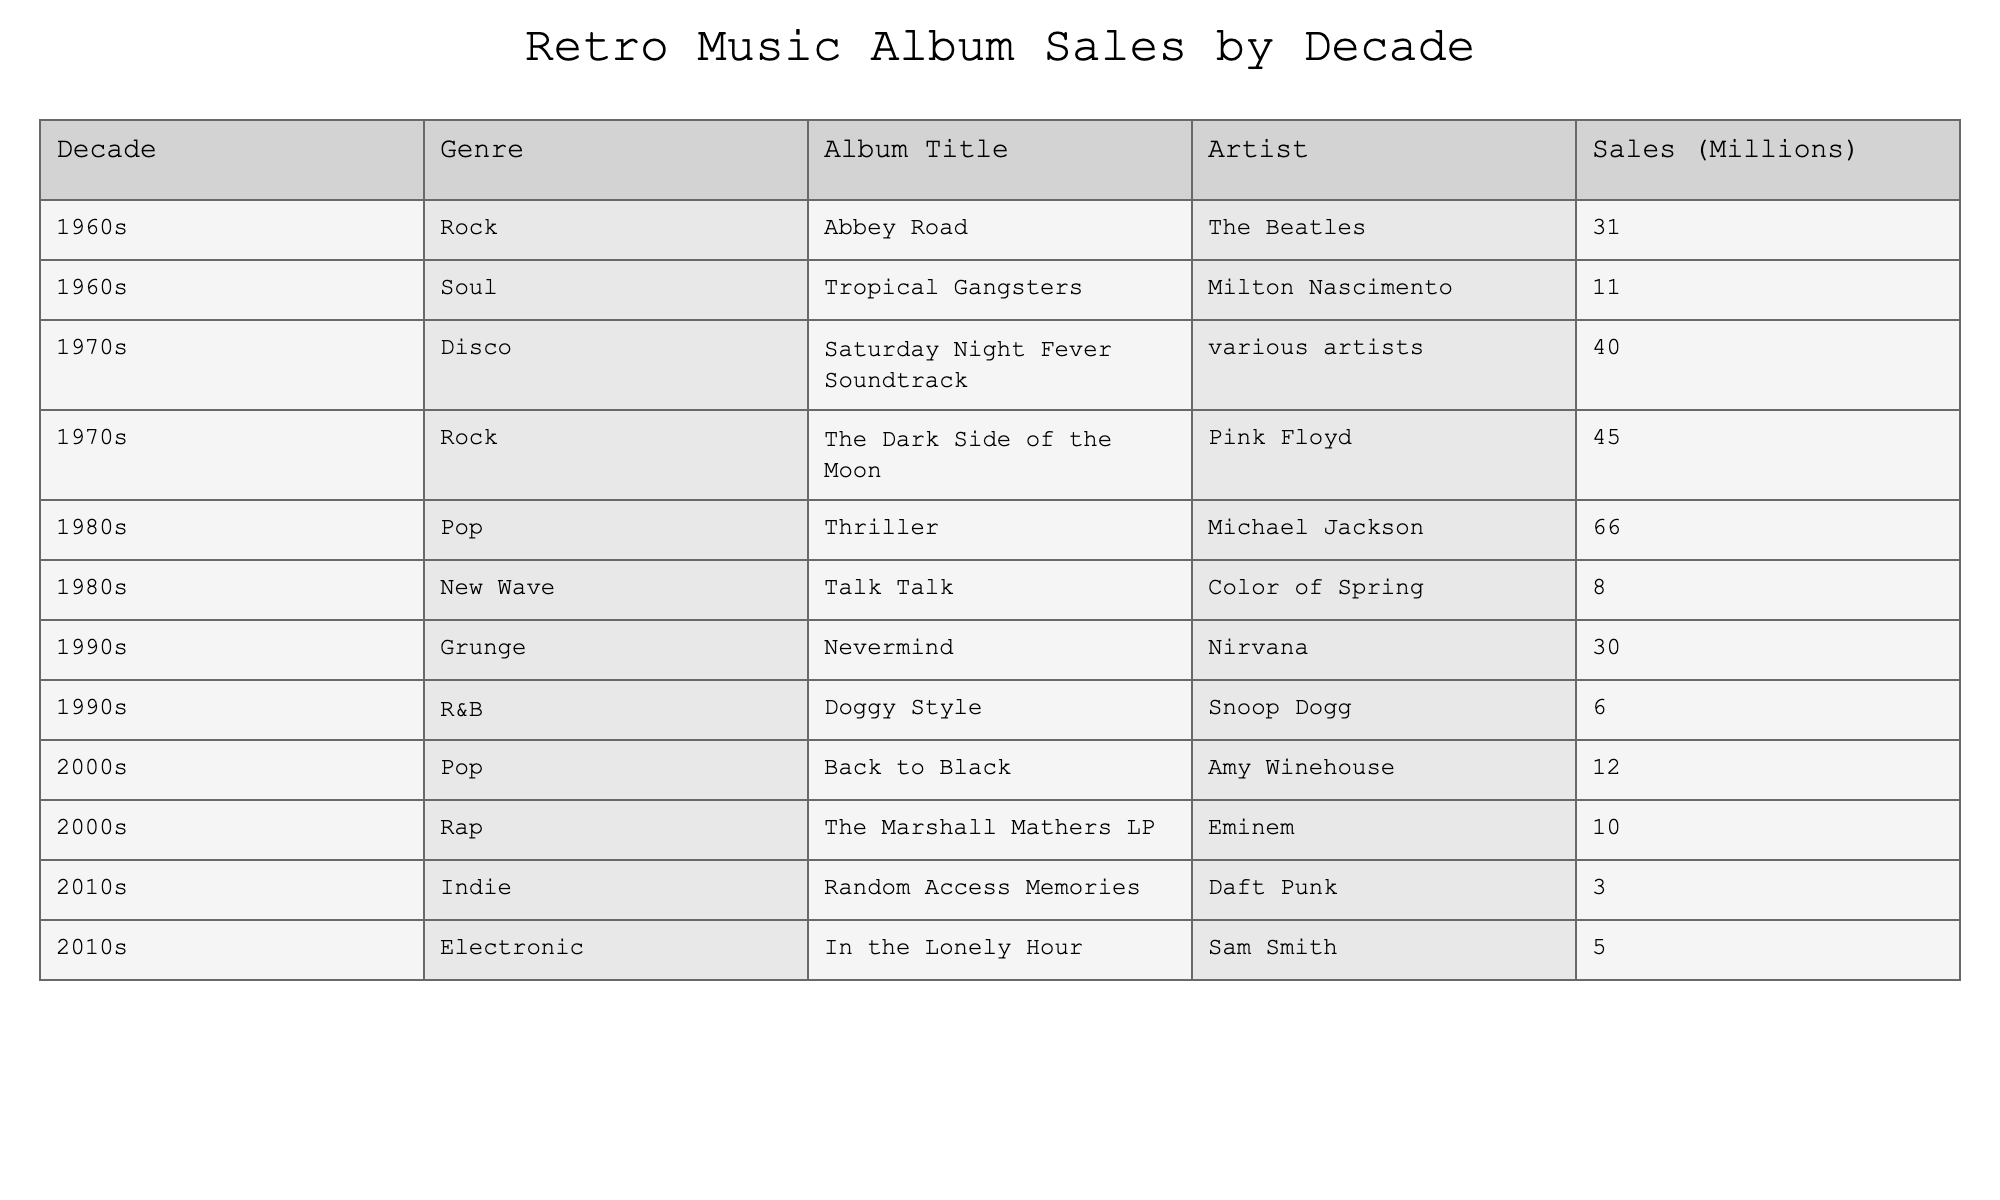What was the highest-selling album of the 1980s? The only album listed from the 1980s is "Thriller" by Michael Jackson, which has sales of 66 million. This is the highest recorded figure in that decade.
Answer: 66 million What genre had the most sales in the 1970s? In the 1970s, the highest-selling album is the "Saturday Night Fever Soundtrack" with 40 million in sales, but "The Dark Side of the Moon" by Pink Floyd sold even more at 45 million. Both are in the disco and rock genres respectively, but rock had the highest individual album sales in that decade.
Answer: Rock How many million albums did the soul genre sell in the 1960s? Milton Nascimento's "Tropical Gangsters" is the only soul album listed for the 1960s and sold 11 million copies.
Answer: 11 million Which decade had the lowest total album sales? Adding up the sales for all albums in each decade, the 2010s had the lowest total, with 3 million for "Random Access Memories" and 5 million for "In the Lonely Hour," resulting in a total of 8 million.
Answer: 8 million Was "Nevermind" by Nirvana the best-selling album of the 1990s? "Nevermind" indeed sold 30 million copies, but it is not clear if it was the best-selling album without comparing additional potential titles that might be missing. We only see one other album, "Doggy Style," which sold 6 million, suggesting "Nevermind" is likely the highest-selling.
Answer: Yes What is the average sales figure for the albums in the 2000s? The albums from the 2000s total 22 million (12 million for "Back to Black" and 10 million for "The Marshall Mathers LP"). Dividing this by the 2 albums gives an average of 11 million.
Answer: 11 million Which artist had the most successful album across all decades shown? Evaluating sales across all years, Michael Jackson's "Thriller" stands at 66 million, which is the highest single album sales among all listed albums from different decades.
Answer: Michael Jackson What is the difference in sales between the highest and lowest-selling albums in the table? Evaluating the highest-selling album "Thriller" at 66 million and the lowest-seller "Random Access Memories" at 3 million, the difference is 66 - 3 = 63 million.
Answer: 63 million Which genre had the most albums listed in the table? Evaluating through the data, we can see that rock and pop each have two entries (such as albums from The Beatles and Pink Floyd for rock, and Michael Jackson and Amy Winehouse for pop). Other genres have only one entry each.
Answer: Rock and Pop 